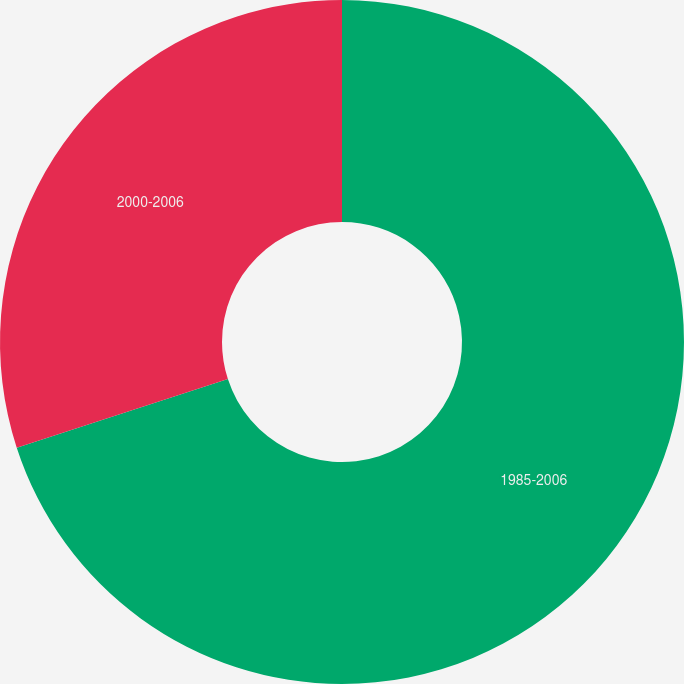Convert chart. <chart><loc_0><loc_0><loc_500><loc_500><pie_chart><fcel>1985-2006<fcel>2000-2006<nl><fcel>70.0%<fcel>30.0%<nl></chart> 